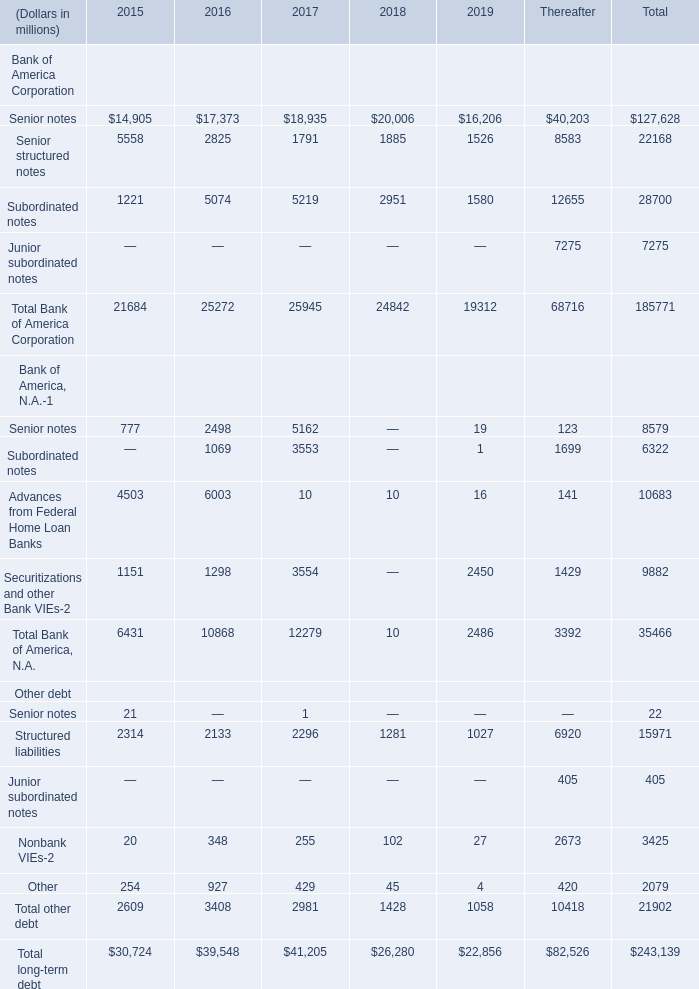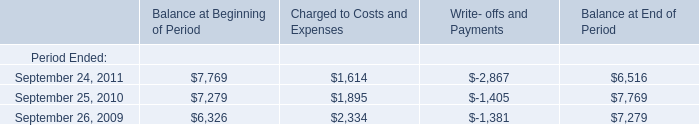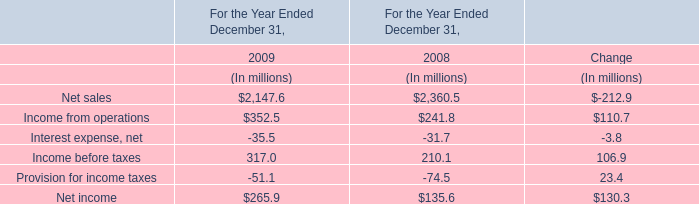What is the average amount of September 26, 2009 of Balance at End of Period, and Senior structured notes of 2017 ? 
Computations: ((7279.0 + 1791.0) / 2)
Answer: 4535.0. 